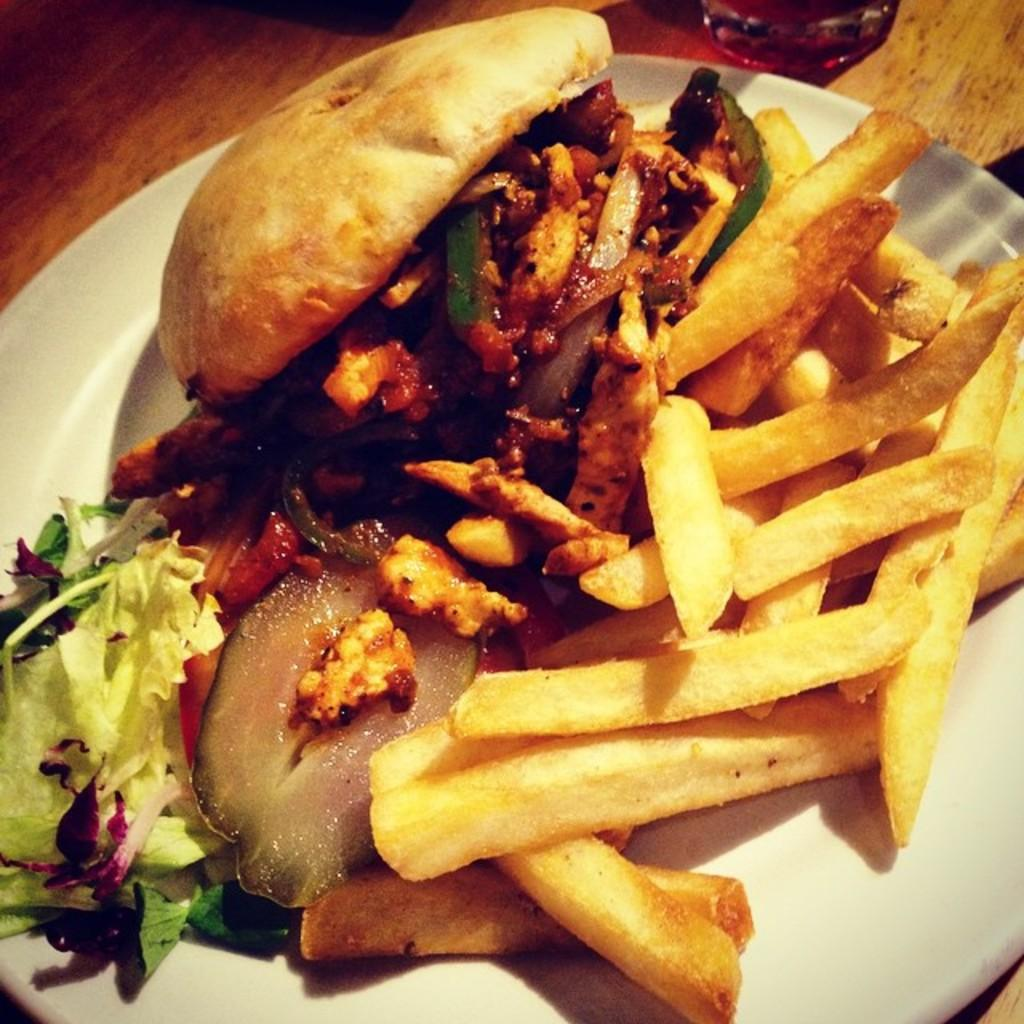What is present in the image? There is food in the image. How is the food arranged or presented? The food is in a plate. Is there a clover plant visible in the image? There is no clover plant present in the image; it features food in a plate. 